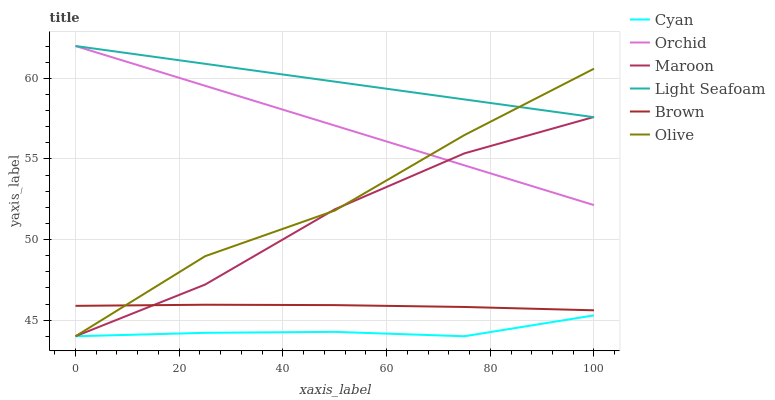Does Maroon have the minimum area under the curve?
Answer yes or no. No. Does Maroon have the maximum area under the curve?
Answer yes or no. No. Is Maroon the smoothest?
Answer yes or no. No. Is Maroon the roughest?
Answer yes or no. No. Does Light Seafoam have the lowest value?
Answer yes or no. No. Does Maroon have the highest value?
Answer yes or no. No. Is Cyan less than Orchid?
Answer yes or no. Yes. Is Brown greater than Cyan?
Answer yes or no. Yes. Does Cyan intersect Orchid?
Answer yes or no. No. 